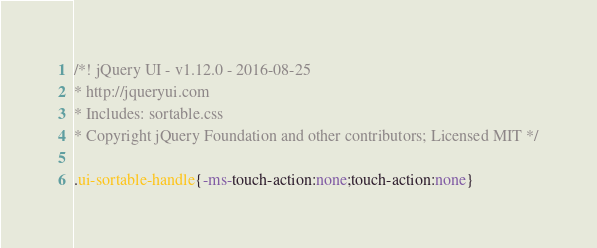Convert code to text. <code><loc_0><loc_0><loc_500><loc_500><_CSS_>/*! jQuery UI - v1.12.0 - 2016-08-25
* http://jqueryui.com
* Includes: sortable.css
* Copyright jQuery Foundation and other contributors; Licensed MIT */

.ui-sortable-handle{-ms-touch-action:none;touch-action:none}</code> 